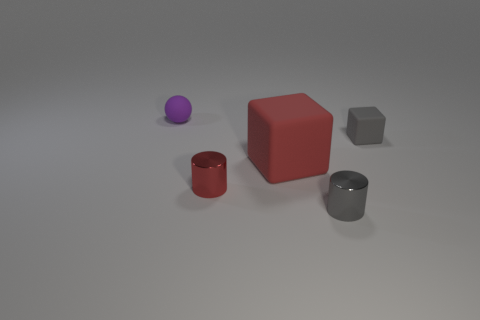Add 3 cubes. How many objects exist? 8 Subtract all gray cylinders. How many cylinders are left? 1 Subtract all cylinders. How many objects are left? 3 Subtract 1 blocks. How many blocks are left? 1 Subtract all blue balls. Subtract all blue cubes. How many balls are left? 1 Subtract all small purple matte spheres. Subtract all small red rubber cubes. How many objects are left? 4 Add 5 small matte spheres. How many small matte spheres are left? 6 Add 3 small purple spheres. How many small purple spheres exist? 4 Subtract 1 red cylinders. How many objects are left? 4 